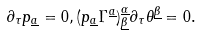<formula> <loc_0><loc_0><loc_500><loc_500>\partial _ { \tau } p _ { \underline { a } } = 0 , ( p _ { \underline { a } } \Gamma ^ { \underline { a } } ) _ { \underline { \beta } } ^ { \underline { \alpha } } \partial _ { \tau } \theta ^ { \underline { \beta } } = 0 .</formula> 